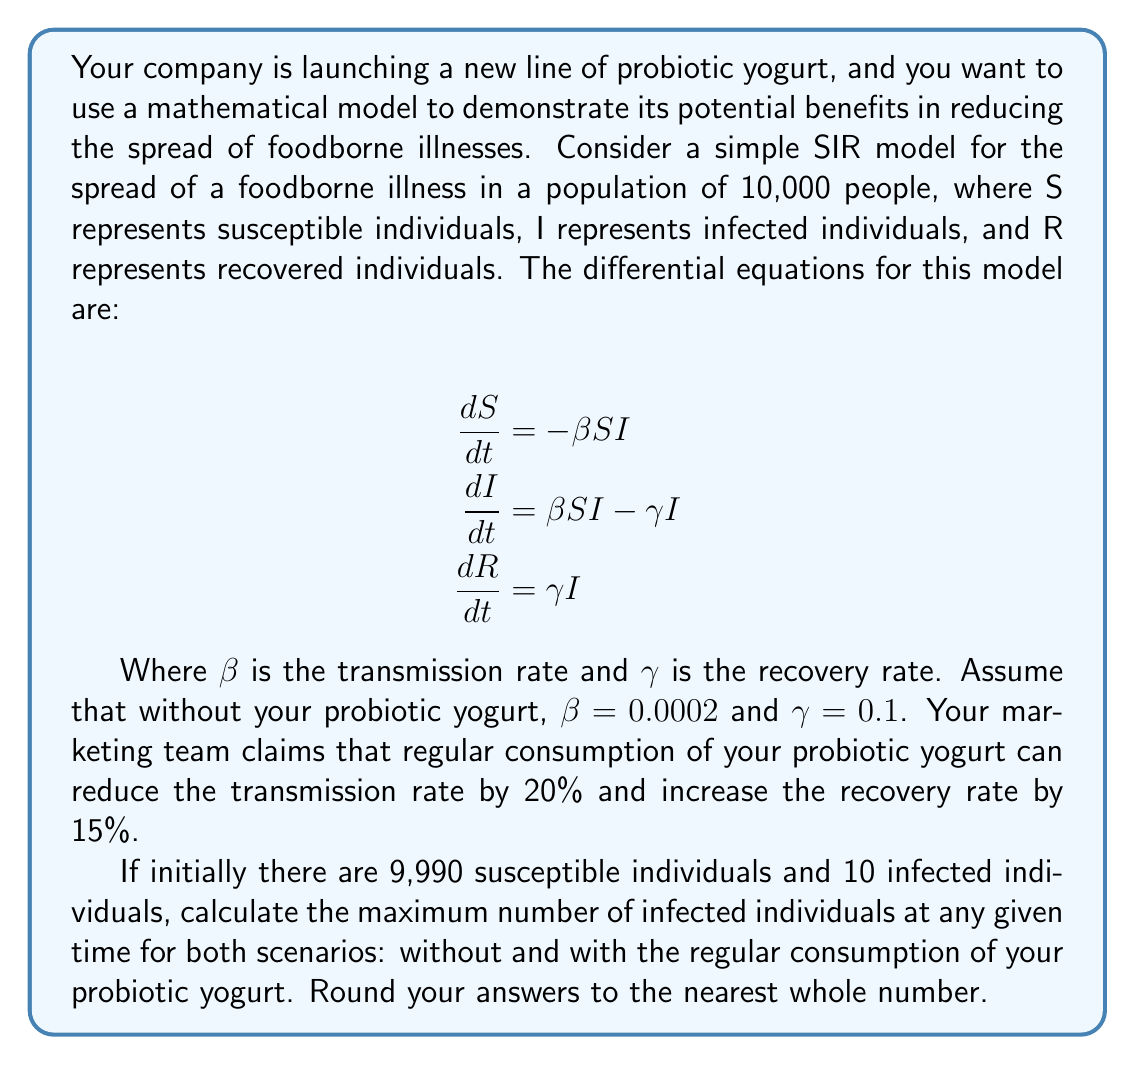Help me with this question. To solve this problem, we need to use the SIR model and find the maximum value of I (infected individuals) for both scenarios. We'll use the fact that the maximum number of infected individuals occurs when $\frac{dI}{dt} = 0$.

1. Without probiotic yogurt:
   $\beta = 0.0002$, $\gamma = 0.1$

2. With probiotic yogurt:
   $\beta_{new} = 0.0002 \times (1 - 0.2) = 0.00016$
   $\gamma_{new} = 0.1 \times (1 + 0.15) = 0.115$

For both scenarios:

When $\frac{dI}{dt} = 0$, we have:
$$\beta SI - \gamma I = 0$$
$$\beta S = \gamma$$
$$S = \frac{\gamma}{\beta}$$

The total population $N = S + I + R = 10,000$

At the peak of infection:
$$I_{max} = N - S - R = N - \frac{\gamma}{\beta} - R$$

We don't know R at this point, but we can use the relation:
$$R = N \left(1 - \frac{\gamma}{\beta N} \ln \frac{\beta N}{\gamma}\right)$$

Now we can calculate $I_{max}$ for both scenarios:

1. Without probiotic yogurt:
   $$R = 10000 \left(1 - \frac{0.1}{0.0002 \times 10000} \ln \frac{0.0002 \times 10000}{0.1}\right) = 3973.97$$
   $$I_{max} = 10000 - \frac{0.1}{0.0002} - 3973.97 = 1526.03$$

2. With probiotic yogurt:
   $$R = 10000 \left(1 - \frac{0.115}{0.00016 \times 10000} \ln \frac{0.00016 \times 10000}{0.115}\right) = 2757.81$$
   $$I_{max} = 10000 - \frac{0.115}{0.00016} - 2757.81 = 529.94$$

Rounding to the nearest whole number, we get our final answers.
Answer: Without probiotic yogurt: 1526 infected individuals
With probiotic yogurt: 530 infected individuals 